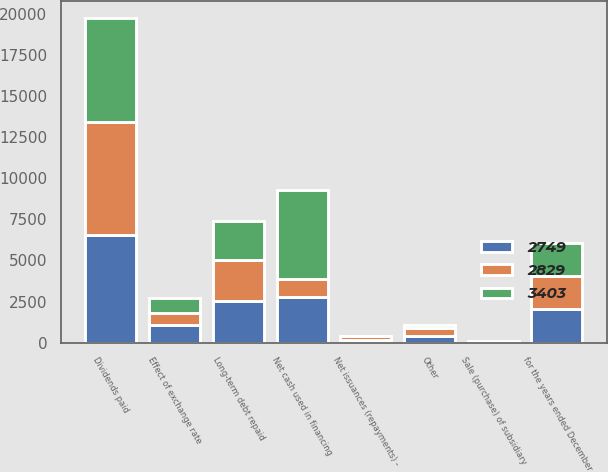Convert chart. <chart><loc_0><loc_0><loc_500><loc_500><stacked_bar_chart><ecel><fcel>for the years ended December<fcel>Net issuances (repayments) -<fcel>Long-term debt repaid<fcel>Dividends paid<fcel>Sale (purchase) of subsidiary<fcel>Other<fcel>Net cash used in financing<fcel>Effect of exchange rate<nl><fcel>2829<fcel>2018<fcel>255<fcel>2484<fcel>6885<fcel>81<fcel>456<fcel>1085<fcel>685<nl><fcel>2749<fcel>2017<fcel>127<fcel>2551<fcel>6520<fcel>5<fcel>426<fcel>2769<fcel>1085<nl><fcel>3403<fcel>2016<fcel>12<fcel>2393<fcel>6378<fcel>7<fcel>173<fcel>5413<fcel>965<nl></chart> 